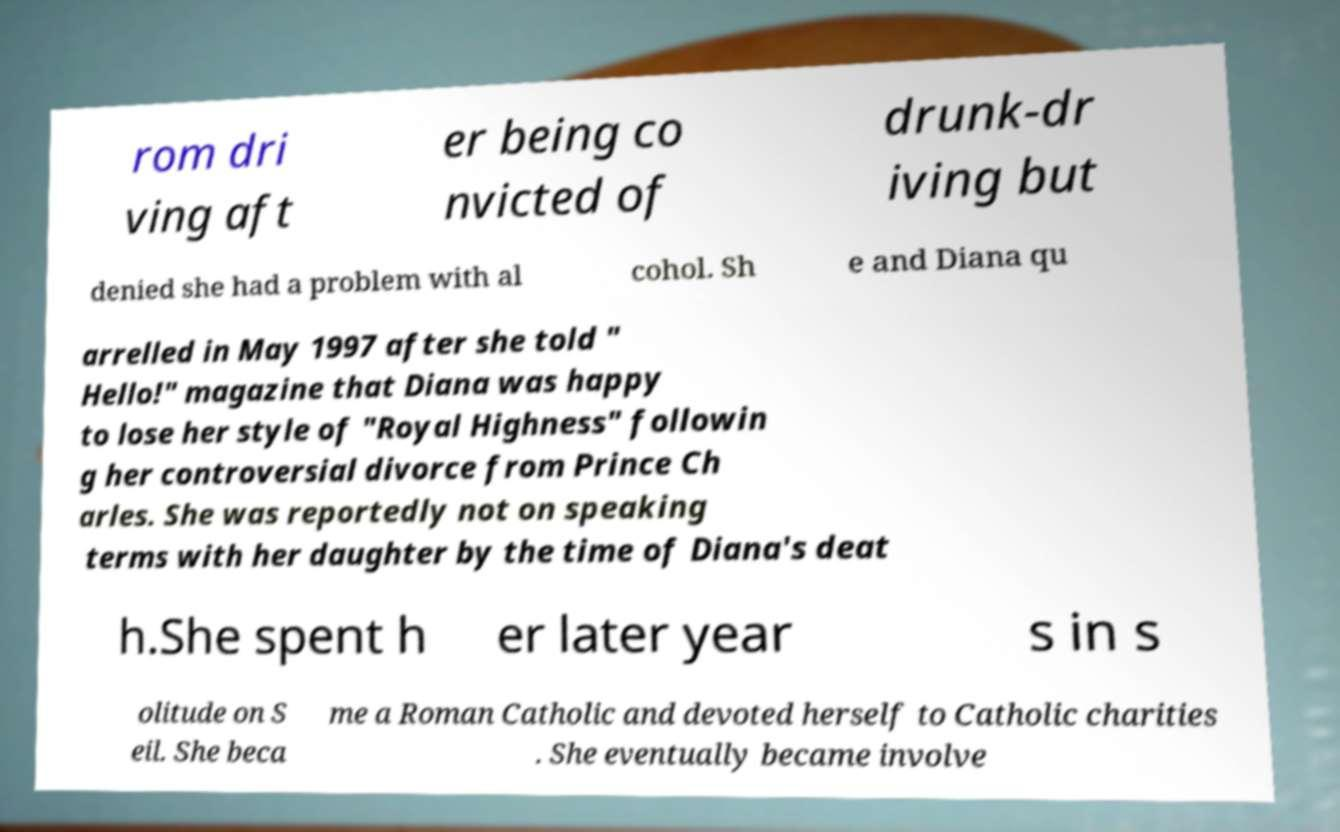Please identify and transcribe the text found in this image. rom dri ving aft er being co nvicted of drunk-dr iving but denied she had a problem with al cohol. Sh e and Diana qu arrelled in May 1997 after she told " Hello!" magazine that Diana was happy to lose her style of "Royal Highness" followin g her controversial divorce from Prince Ch arles. She was reportedly not on speaking terms with her daughter by the time of Diana's deat h.She spent h er later year s in s olitude on S eil. She beca me a Roman Catholic and devoted herself to Catholic charities . She eventually became involve 